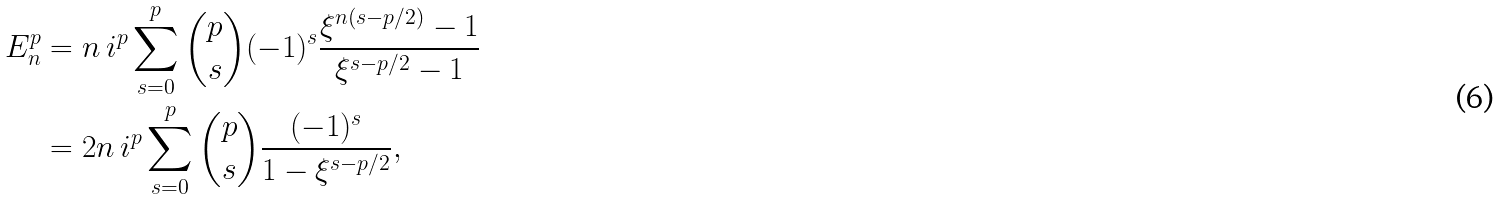Convert formula to latex. <formula><loc_0><loc_0><loc_500><loc_500>E ^ { p } _ { n } & = n \, i ^ { p } \sum _ { s = 0 } ^ { p } \binom { p } { s } ( - 1 ) ^ { s } \frac { \xi ^ { n ( s - p / 2 ) } - 1 } { \xi ^ { s - p / 2 } - 1 } \\ & = 2 n \, i ^ { p } \sum _ { s = 0 } ^ { p } \binom { p } { s } \frac { ( - 1 ) ^ { s } } { 1 - \xi ^ { s - p / 2 } } ,</formula> 